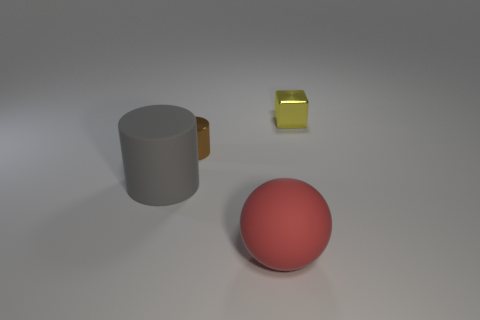Add 1 small green metal cubes. How many objects exist? 5 Subtract all cubes. How many objects are left? 3 Add 4 big red things. How many big red things are left? 5 Add 3 big red rubber balls. How many big red rubber balls exist? 4 Subtract 0 blue balls. How many objects are left? 4 Subtract all tiny blue shiny spheres. Subtract all brown metallic cylinders. How many objects are left? 3 